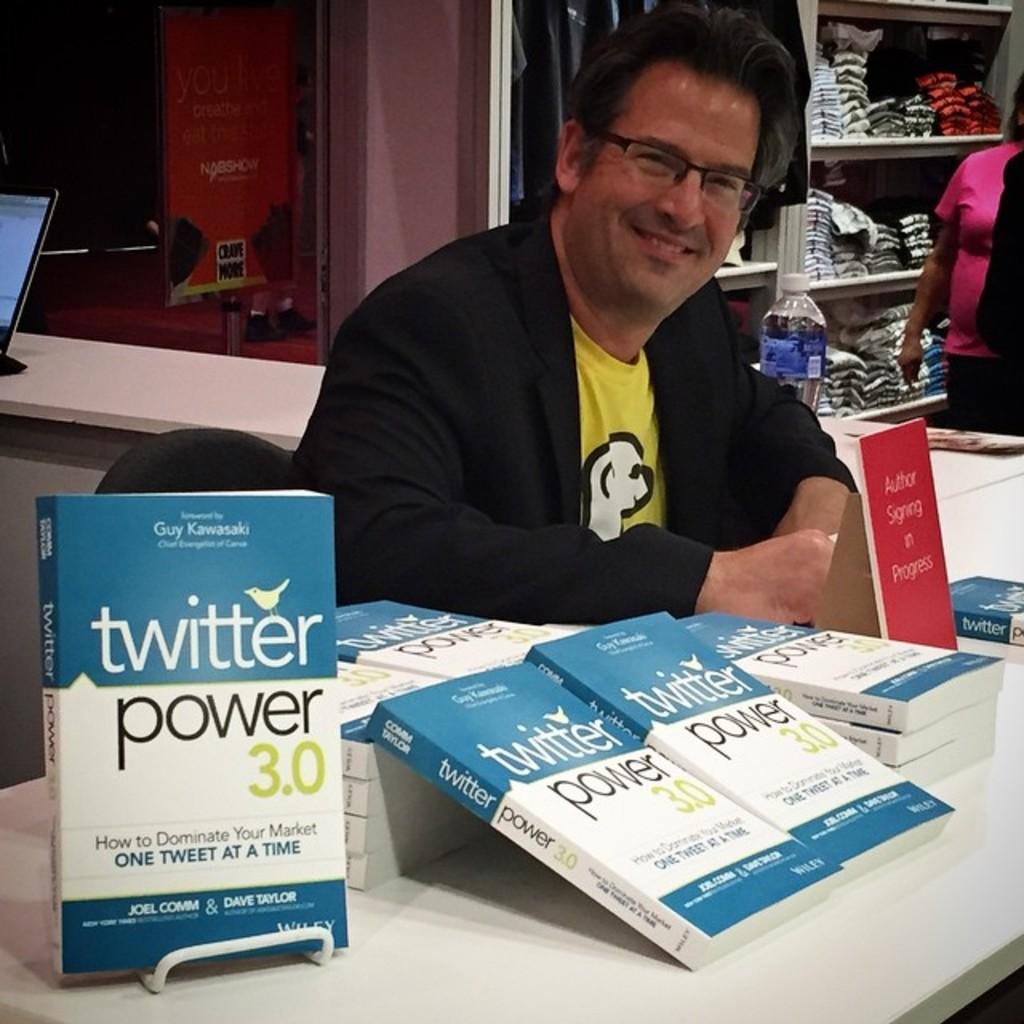Who's the author of this book?
Provide a succinct answer. Joel comm & dave taylor. What is the title of this book?
Keep it short and to the point. Twitter power 3.0. 